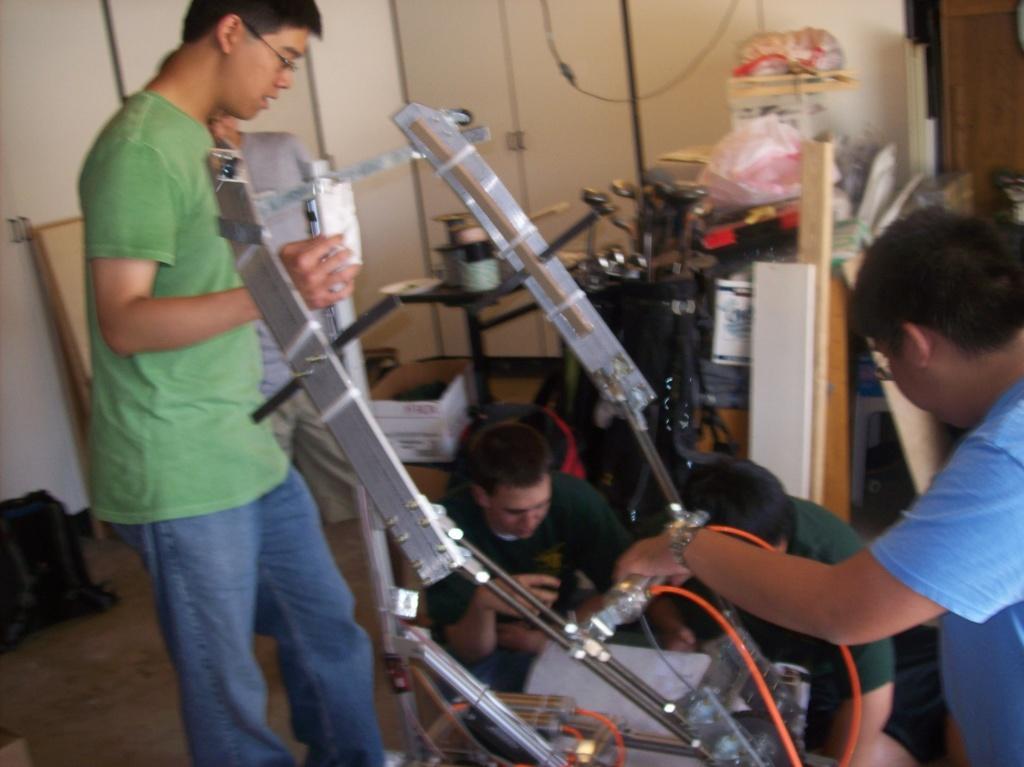Describe this image in one or two sentences. In front of the image there are people and there are some objects on the floor. In the background of the image there is a wall. 